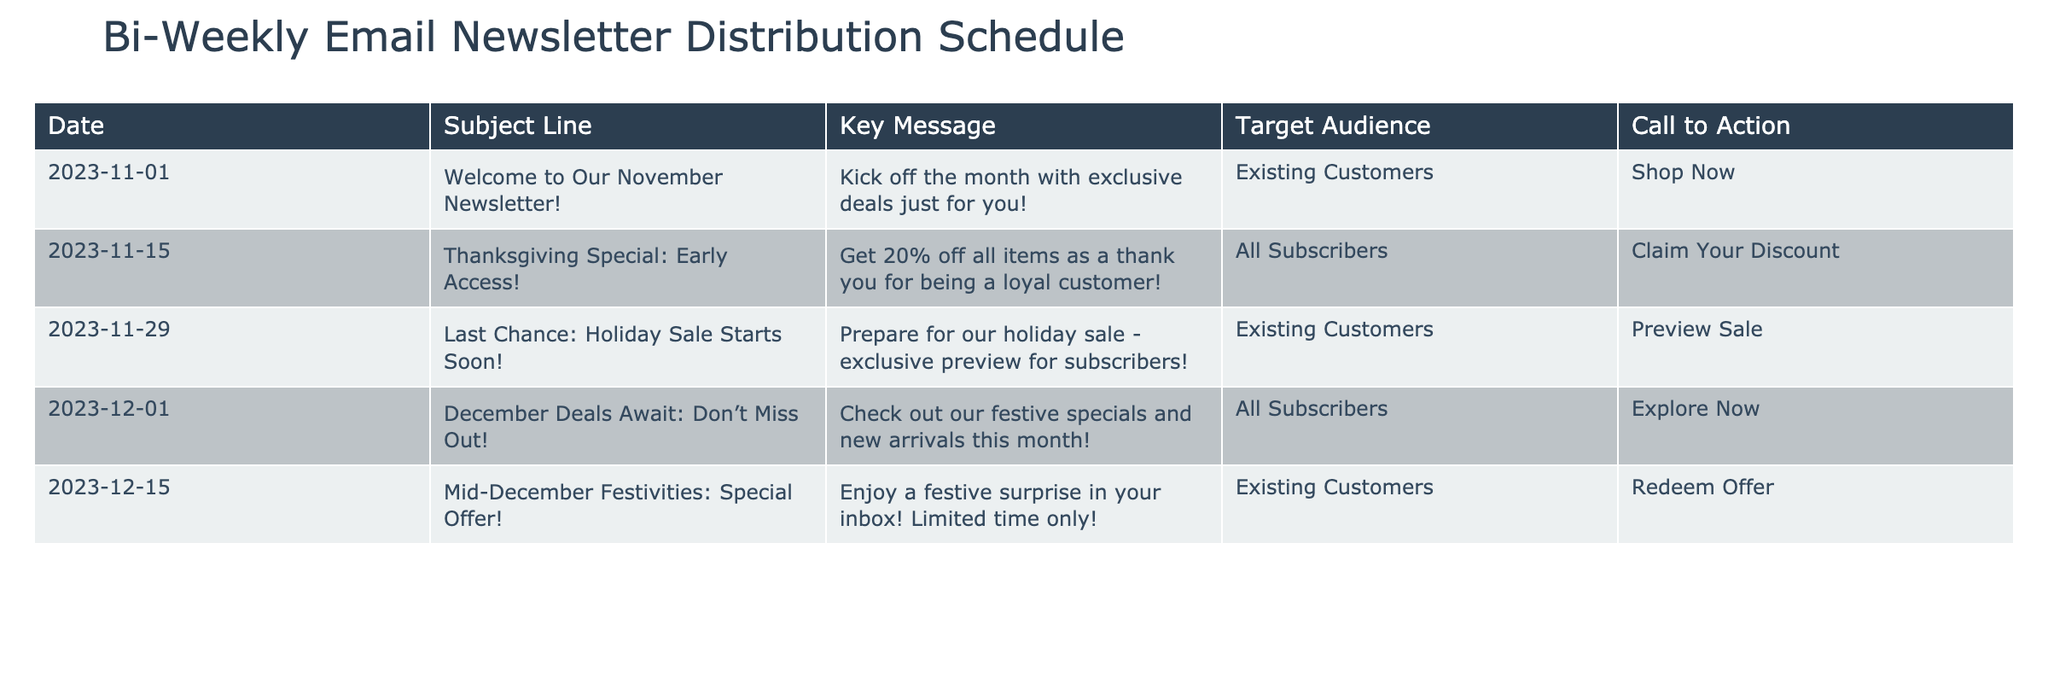What is the subject line of the newsletter scheduled for November 15, 2023? The subject line for the newsletter on November 15, 2023, can be found in the "Subject Line" column of the corresponding row. It reads, "Thanksgiving Special: Early Access!"
Answer: Thanksgiving Special: Early Access! How many newsletters are targeted to existing customers? By counting the rows where the "Target Audience" is labeled as "Existing Customers", we find there are three such newsletters scheduled: on November 1, November 29, and December 15.
Answer: 3 Which newsletter has a call to action of "Explore Now"? To find the newsletter with this specific call to action, I look along the "Call to Action" column. The row for December 1, 2023, shows "Explore Now".
Answer: December 1, 2023 Is there a newsletter with a subject line related to "holiday"? I can look through the "Subject Line" column to check for variations of the word "holiday". The subject line for November 29 includes "Holiday Sale". Therefore, the answer is yes.
Answer: Yes What is the key message for the newsletter scheduled on November 29, and how does it relate to the upcoming holiday season? The key message on November 29 states, "Prepare for our holiday sale - exclusive preview for subscribers!" This indicates that the newsletter is designed to prepare customers for the upcoming holiday sales, making it relevant due to the timing before the holidays.
Answer: Prepare for our holiday sale - exclusive preview for subscribers! Which newsletter has the latest date, and what is its key message? The latest date in the schedule is December 15, 2023. Checking the related information in that row, the key message is "Enjoy a festive surprise in your inbox! Limited time only!".
Answer: December 15, 2023; Enjoy a festive surprise in your inbox! Limited time only! How does the call to action change from the first newsletter to the last newsletter? The first newsletter encourages the audience to "Shop Now", while the last newsletter prompts them to "Redeem Offer". This indicates a shift from initial engagement to a focus on providing an exclusive offer closer to the holiday season.
Answer: From "Shop Now" to "Redeem Offer" What percentage of all newsletters are focused on existing customers? There are 5 newsletters in total, 3 of which target existing customers. To find the percentage, I calculate (3/5) * 100 = 60%.
Answer: 60% 